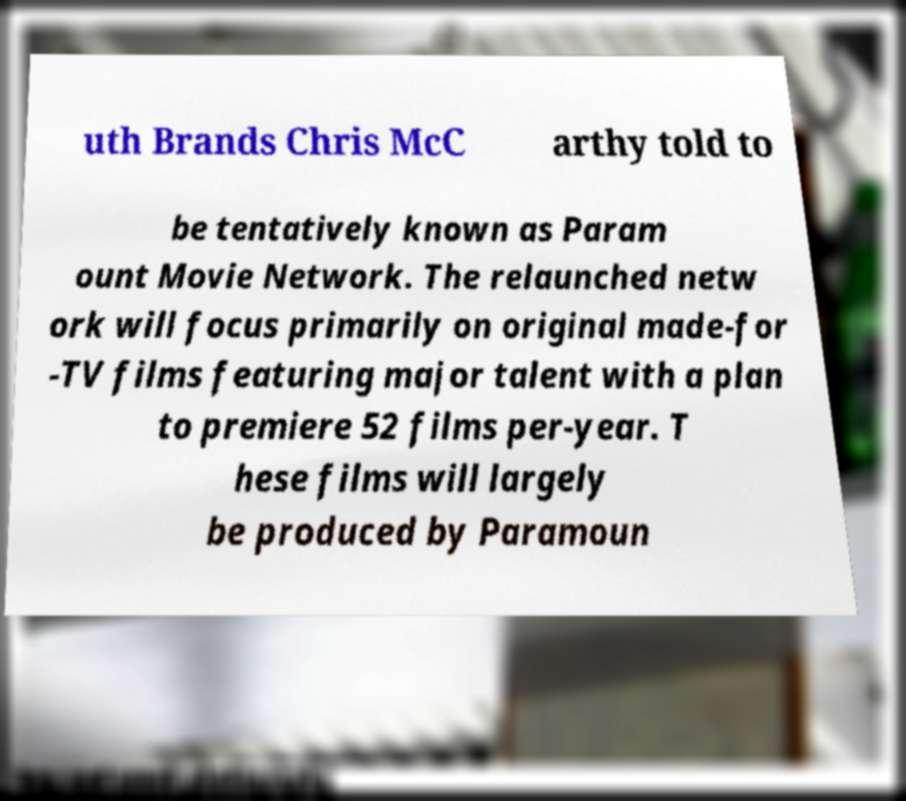Could you assist in decoding the text presented in this image and type it out clearly? uth Brands Chris McC arthy told to be tentatively known as Param ount Movie Network. The relaunched netw ork will focus primarily on original made-for -TV films featuring major talent with a plan to premiere 52 films per-year. T hese films will largely be produced by Paramoun 